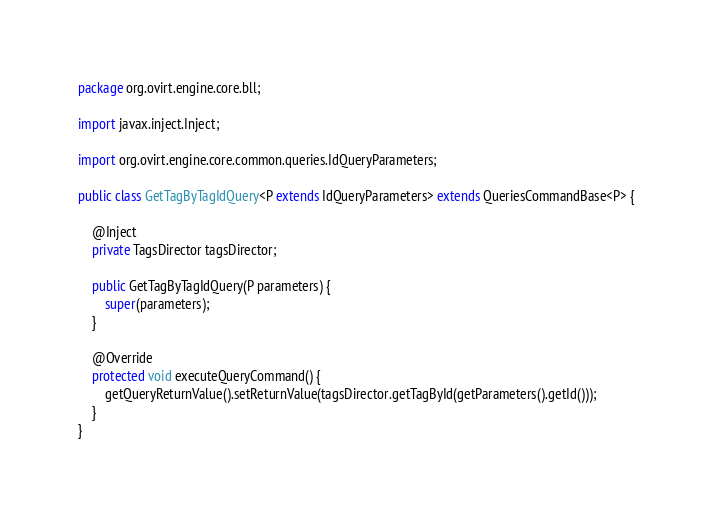Convert code to text. <code><loc_0><loc_0><loc_500><loc_500><_Java_>package org.ovirt.engine.core.bll;

import javax.inject.Inject;

import org.ovirt.engine.core.common.queries.IdQueryParameters;

public class GetTagByTagIdQuery<P extends IdQueryParameters> extends QueriesCommandBase<P> {

    @Inject
    private TagsDirector tagsDirector;

    public GetTagByTagIdQuery(P parameters) {
        super(parameters);
    }

    @Override
    protected void executeQueryCommand() {
        getQueryReturnValue().setReturnValue(tagsDirector.getTagById(getParameters().getId()));
    }
}
</code> 